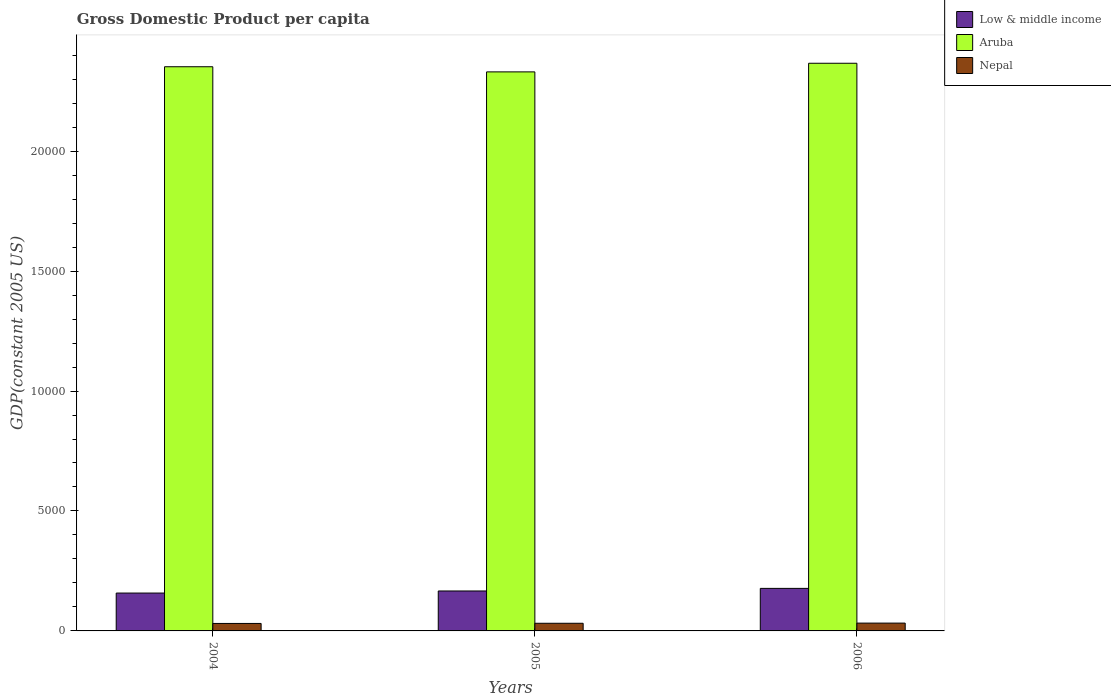How many different coloured bars are there?
Give a very brief answer. 3. Are the number of bars on each tick of the X-axis equal?
Ensure brevity in your answer.  Yes. How many bars are there on the 2nd tick from the right?
Provide a succinct answer. 3. What is the label of the 3rd group of bars from the left?
Provide a short and direct response. 2006. What is the GDP per capita in Aruba in 2005?
Ensure brevity in your answer.  2.33e+04. Across all years, what is the maximum GDP per capita in Low & middle income?
Provide a short and direct response. 1772.86. Across all years, what is the minimum GDP per capita in Low & middle income?
Offer a very short reply. 1578.12. What is the total GDP per capita in Aruba in the graph?
Offer a very short reply. 7.05e+04. What is the difference between the GDP per capita in Low & middle income in 2005 and that in 2006?
Keep it short and to the point. -107.75. What is the difference between the GDP per capita in Nepal in 2006 and the GDP per capita in Aruba in 2004?
Offer a terse response. -2.32e+04. What is the average GDP per capita in Low & middle income per year?
Offer a terse response. 1672.03. In the year 2005, what is the difference between the GDP per capita in Nepal and GDP per capita in Aruba?
Ensure brevity in your answer.  -2.30e+04. In how many years, is the GDP per capita in Nepal greater than 19000 US$?
Give a very brief answer. 0. What is the ratio of the GDP per capita in Nepal in 2004 to that in 2006?
Offer a very short reply. 0.96. Is the GDP per capita in Aruba in 2005 less than that in 2006?
Make the answer very short. Yes. Is the difference between the GDP per capita in Nepal in 2004 and 2006 greater than the difference between the GDP per capita in Aruba in 2004 and 2006?
Your response must be concise. Yes. What is the difference between the highest and the second highest GDP per capita in Aruba?
Make the answer very short. 145.06. What is the difference between the highest and the lowest GDP per capita in Nepal?
Offer a very short reply. 14. In how many years, is the GDP per capita in Aruba greater than the average GDP per capita in Aruba taken over all years?
Offer a very short reply. 2. Is the sum of the GDP per capita in Nepal in 2005 and 2006 greater than the maximum GDP per capita in Aruba across all years?
Ensure brevity in your answer.  No. What does the 2nd bar from the left in 2006 represents?
Provide a succinct answer. Aruba. What does the 3rd bar from the right in 2006 represents?
Provide a short and direct response. Low & middle income. How many bars are there?
Your answer should be compact. 9. How many years are there in the graph?
Make the answer very short. 3. What is the difference between two consecutive major ticks on the Y-axis?
Provide a short and direct response. 5000. Does the graph contain grids?
Offer a very short reply. No. What is the title of the graph?
Give a very brief answer. Gross Domestic Product per capita. What is the label or title of the Y-axis?
Keep it short and to the point. GDP(constant 2005 US). What is the GDP(constant 2005 US) of Low & middle income in 2004?
Offer a terse response. 1578.12. What is the GDP(constant 2005 US) of Aruba in 2004?
Offer a terse response. 2.35e+04. What is the GDP(constant 2005 US) of Nepal in 2004?
Offer a very short reply. 311.81. What is the GDP(constant 2005 US) of Low & middle income in 2005?
Your answer should be very brief. 1665.11. What is the GDP(constant 2005 US) in Aruba in 2005?
Your answer should be compact. 2.33e+04. What is the GDP(constant 2005 US) in Nepal in 2005?
Provide a short and direct response. 318.75. What is the GDP(constant 2005 US) in Low & middle income in 2006?
Ensure brevity in your answer.  1772.86. What is the GDP(constant 2005 US) of Aruba in 2006?
Offer a terse response. 2.37e+04. What is the GDP(constant 2005 US) in Nepal in 2006?
Your answer should be very brief. 325.8. Across all years, what is the maximum GDP(constant 2005 US) of Low & middle income?
Your answer should be compact. 1772.86. Across all years, what is the maximum GDP(constant 2005 US) of Aruba?
Keep it short and to the point. 2.37e+04. Across all years, what is the maximum GDP(constant 2005 US) in Nepal?
Your answer should be very brief. 325.8. Across all years, what is the minimum GDP(constant 2005 US) of Low & middle income?
Ensure brevity in your answer.  1578.12. Across all years, what is the minimum GDP(constant 2005 US) in Aruba?
Your response must be concise. 2.33e+04. Across all years, what is the minimum GDP(constant 2005 US) of Nepal?
Your answer should be compact. 311.81. What is the total GDP(constant 2005 US) in Low & middle income in the graph?
Make the answer very short. 5016.1. What is the total GDP(constant 2005 US) of Aruba in the graph?
Provide a succinct answer. 7.05e+04. What is the total GDP(constant 2005 US) of Nepal in the graph?
Your answer should be very brief. 956.35. What is the difference between the GDP(constant 2005 US) in Low & middle income in 2004 and that in 2005?
Offer a terse response. -86.99. What is the difference between the GDP(constant 2005 US) of Aruba in 2004 and that in 2005?
Your answer should be compact. 214.74. What is the difference between the GDP(constant 2005 US) in Nepal in 2004 and that in 2005?
Ensure brevity in your answer.  -6.94. What is the difference between the GDP(constant 2005 US) of Low & middle income in 2004 and that in 2006?
Offer a very short reply. -194.74. What is the difference between the GDP(constant 2005 US) in Aruba in 2004 and that in 2006?
Provide a short and direct response. -145.06. What is the difference between the GDP(constant 2005 US) of Nepal in 2004 and that in 2006?
Provide a short and direct response. -14. What is the difference between the GDP(constant 2005 US) of Low & middle income in 2005 and that in 2006?
Your answer should be very brief. -107.75. What is the difference between the GDP(constant 2005 US) of Aruba in 2005 and that in 2006?
Provide a short and direct response. -359.8. What is the difference between the GDP(constant 2005 US) of Nepal in 2005 and that in 2006?
Keep it short and to the point. -7.05. What is the difference between the GDP(constant 2005 US) in Low & middle income in 2004 and the GDP(constant 2005 US) in Aruba in 2005?
Offer a terse response. -2.17e+04. What is the difference between the GDP(constant 2005 US) of Low & middle income in 2004 and the GDP(constant 2005 US) of Nepal in 2005?
Your answer should be very brief. 1259.37. What is the difference between the GDP(constant 2005 US) in Aruba in 2004 and the GDP(constant 2005 US) in Nepal in 2005?
Your answer should be very brief. 2.32e+04. What is the difference between the GDP(constant 2005 US) in Low & middle income in 2004 and the GDP(constant 2005 US) in Aruba in 2006?
Ensure brevity in your answer.  -2.21e+04. What is the difference between the GDP(constant 2005 US) of Low & middle income in 2004 and the GDP(constant 2005 US) of Nepal in 2006?
Ensure brevity in your answer.  1252.32. What is the difference between the GDP(constant 2005 US) of Aruba in 2004 and the GDP(constant 2005 US) of Nepal in 2006?
Provide a short and direct response. 2.32e+04. What is the difference between the GDP(constant 2005 US) in Low & middle income in 2005 and the GDP(constant 2005 US) in Aruba in 2006?
Offer a terse response. -2.20e+04. What is the difference between the GDP(constant 2005 US) of Low & middle income in 2005 and the GDP(constant 2005 US) of Nepal in 2006?
Make the answer very short. 1339.31. What is the difference between the GDP(constant 2005 US) in Aruba in 2005 and the GDP(constant 2005 US) in Nepal in 2006?
Provide a short and direct response. 2.30e+04. What is the average GDP(constant 2005 US) of Low & middle income per year?
Your answer should be compact. 1672.03. What is the average GDP(constant 2005 US) of Aruba per year?
Offer a terse response. 2.35e+04. What is the average GDP(constant 2005 US) in Nepal per year?
Give a very brief answer. 318.78. In the year 2004, what is the difference between the GDP(constant 2005 US) of Low & middle income and GDP(constant 2005 US) of Aruba?
Ensure brevity in your answer.  -2.19e+04. In the year 2004, what is the difference between the GDP(constant 2005 US) of Low & middle income and GDP(constant 2005 US) of Nepal?
Offer a very short reply. 1266.32. In the year 2004, what is the difference between the GDP(constant 2005 US) in Aruba and GDP(constant 2005 US) in Nepal?
Your answer should be very brief. 2.32e+04. In the year 2005, what is the difference between the GDP(constant 2005 US) in Low & middle income and GDP(constant 2005 US) in Aruba?
Provide a short and direct response. -2.16e+04. In the year 2005, what is the difference between the GDP(constant 2005 US) of Low & middle income and GDP(constant 2005 US) of Nepal?
Keep it short and to the point. 1346.37. In the year 2005, what is the difference between the GDP(constant 2005 US) in Aruba and GDP(constant 2005 US) in Nepal?
Your response must be concise. 2.30e+04. In the year 2006, what is the difference between the GDP(constant 2005 US) in Low & middle income and GDP(constant 2005 US) in Aruba?
Keep it short and to the point. -2.19e+04. In the year 2006, what is the difference between the GDP(constant 2005 US) in Low & middle income and GDP(constant 2005 US) in Nepal?
Your answer should be very brief. 1447.06. In the year 2006, what is the difference between the GDP(constant 2005 US) in Aruba and GDP(constant 2005 US) in Nepal?
Your response must be concise. 2.33e+04. What is the ratio of the GDP(constant 2005 US) of Low & middle income in 2004 to that in 2005?
Your answer should be very brief. 0.95. What is the ratio of the GDP(constant 2005 US) of Aruba in 2004 to that in 2005?
Ensure brevity in your answer.  1.01. What is the ratio of the GDP(constant 2005 US) in Nepal in 2004 to that in 2005?
Offer a terse response. 0.98. What is the ratio of the GDP(constant 2005 US) in Low & middle income in 2004 to that in 2006?
Offer a terse response. 0.89. What is the ratio of the GDP(constant 2005 US) in Nepal in 2004 to that in 2006?
Provide a succinct answer. 0.96. What is the ratio of the GDP(constant 2005 US) of Low & middle income in 2005 to that in 2006?
Provide a short and direct response. 0.94. What is the ratio of the GDP(constant 2005 US) in Nepal in 2005 to that in 2006?
Make the answer very short. 0.98. What is the difference between the highest and the second highest GDP(constant 2005 US) of Low & middle income?
Ensure brevity in your answer.  107.75. What is the difference between the highest and the second highest GDP(constant 2005 US) in Aruba?
Your response must be concise. 145.06. What is the difference between the highest and the second highest GDP(constant 2005 US) in Nepal?
Your answer should be compact. 7.05. What is the difference between the highest and the lowest GDP(constant 2005 US) of Low & middle income?
Give a very brief answer. 194.74. What is the difference between the highest and the lowest GDP(constant 2005 US) of Aruba?
Your response must be concise. 359.8. What is the difference between the highest and the lowest GDP(constant 2005 US) of Nepal?
Provide a succinct answer. 14. 